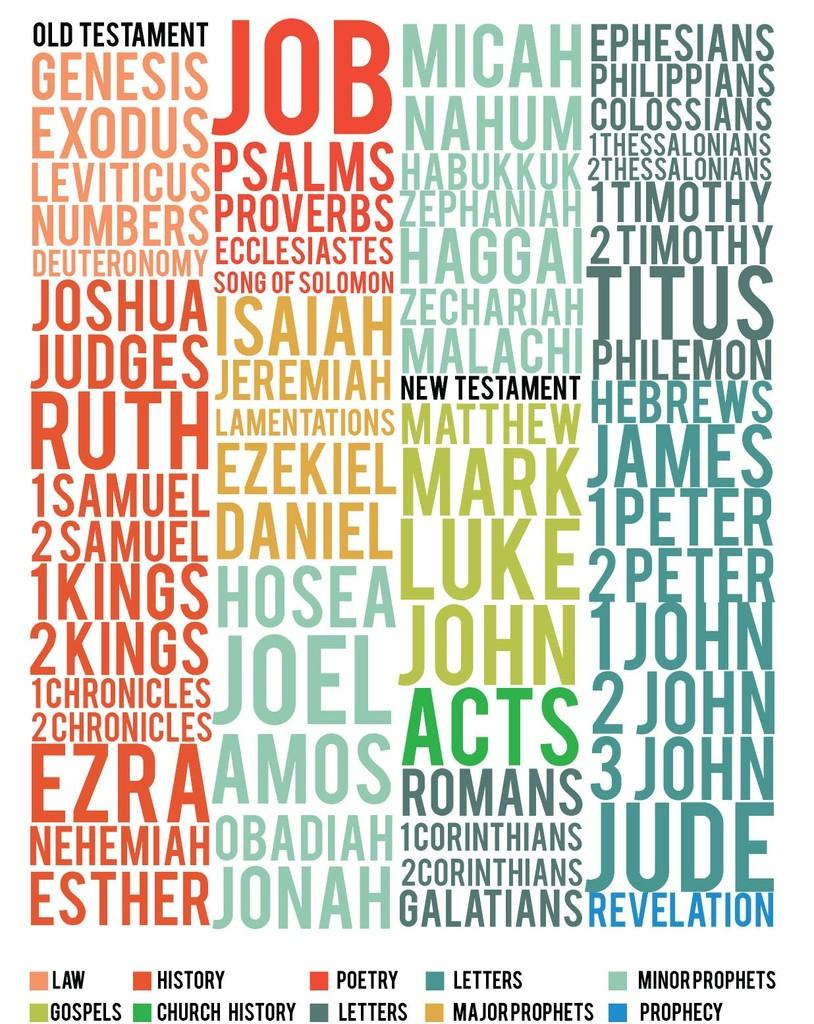What is present in the image that contains information or a message? There is a poster in the image. What can be found on the poster in the image? The poster has text on it. What type of bridge is depicted on the poster in the image? There is no bridge depicted on the poster in the image; the poster only has text on it. 